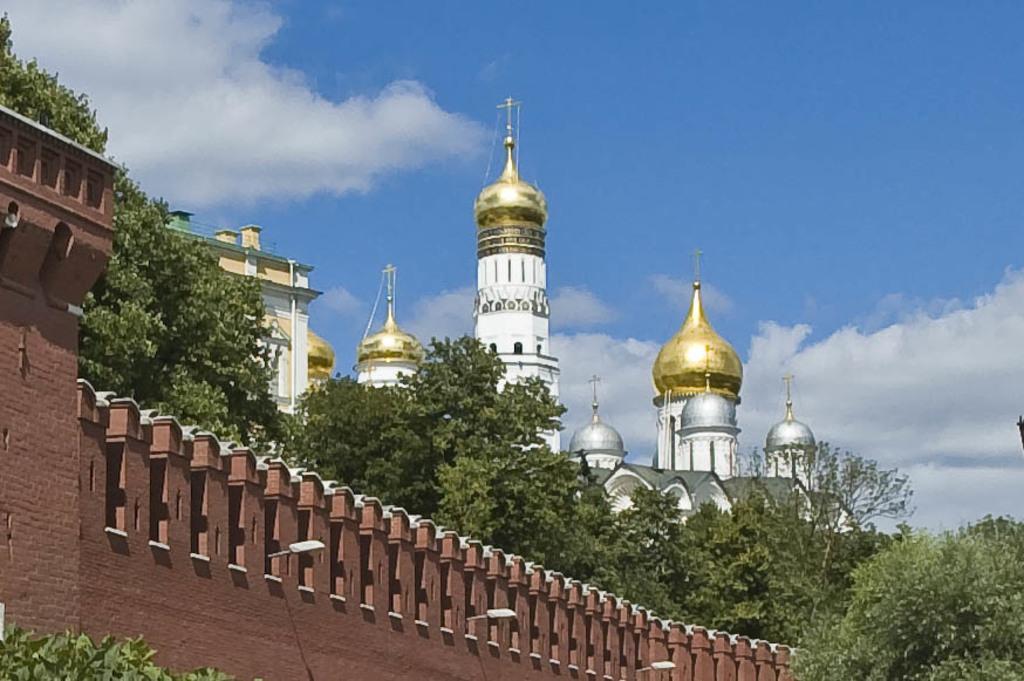Can you describe this image briefly? In this picture we can see a castle, a building and trees. On the left side of the image, there is a wall. At the top of the image, there is the sky. 